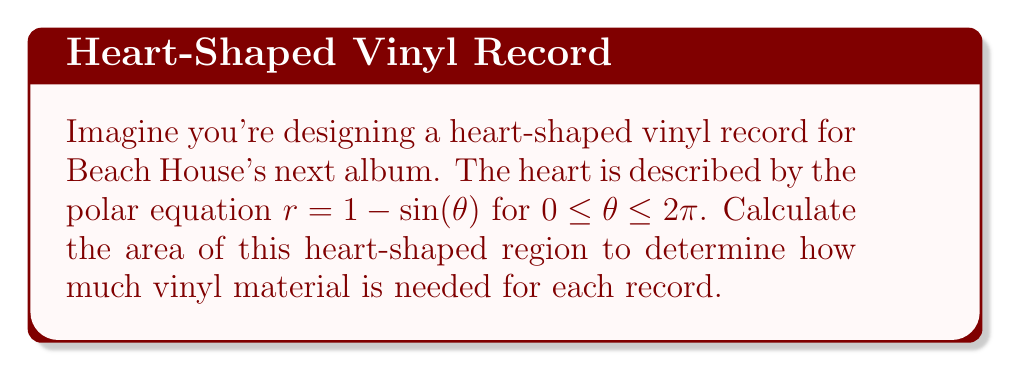Help me with this question. To find the area of the heart-shaped region, we'll use the formula for area in polar coordinates:

$$A = \frac{1}{2} \int_a^b r^2(\theta) d\theta$$

Where $r(\theta) = 1 - \sin(\theta)$ and the limits of integration are from 0 to $2\pi$.

1) First, we square the radius function:
   $$r^2(\theta) = (1 - \sin(\theta))^2 = 1 - 2\sin(\theta) + \sin^2(\theta)$$

2) Now, we set up the integral:
   $$A = \frac{1}{2} \int_0^{2\pi} (1 - 2\sin(\theta) + \sin^2(\theta)) d\theta$$

3) Let's integrate each term separately:
   $$\frac{1}{2} \int_0^{2\pi} 1 d\theta = \frac{1}{2} \theta \Big|_0^{2\pi} = \pi$$
   
   $$-\frac{1}{2} \int_0^{2\pi} 2\sin(\theta) d\theta = -\cos(\theta) \Big|_0^{2\pi} = 0$$
   
   $$\frac{1}{2} \int_0^{2\pi} \sin^2(\theta) d\theta = \frac{1}{2} \left[\frac{\theta}{2} - \frac{\sin(2\theta)}{4}\right]_0^{2\pi} = \frac{\pi}{2}$$

4) Adding these results:
   $$A = \pi + 0 + \frac{\pi}{2} = \frac{3\pi}{2}$$

Therefore, the area of the heart-shaped region is $\frac{3\pi}{2}$ square units.
Answer: $\frac{3\pi}{2}$ square units 